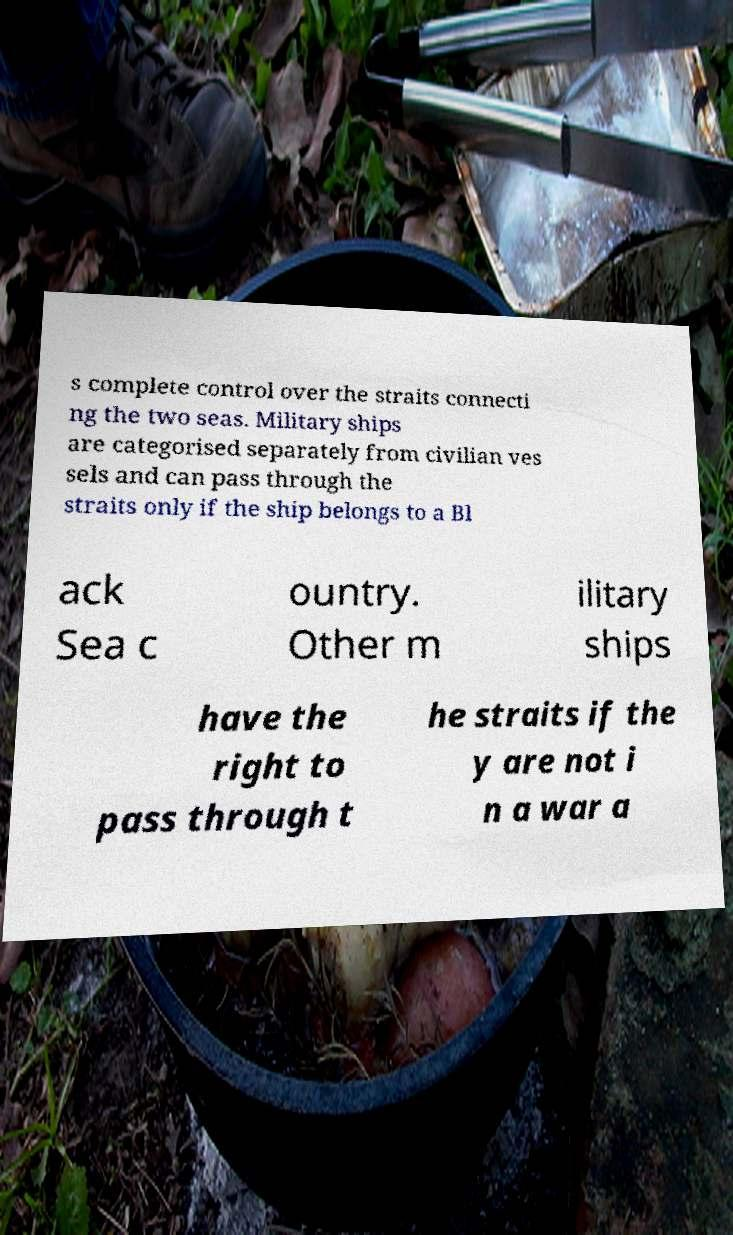Please read and relay the text visible in this image. What does it say? s complete control over the straits connecti ng the two seas. Military ships are categorised separately from civilian ves sels and can pass through the straits only if the ship belongs to a Bl ack Sea c ountry. Other m ilitary ships have the right to pass through t he straits if the y are not i n a war a 